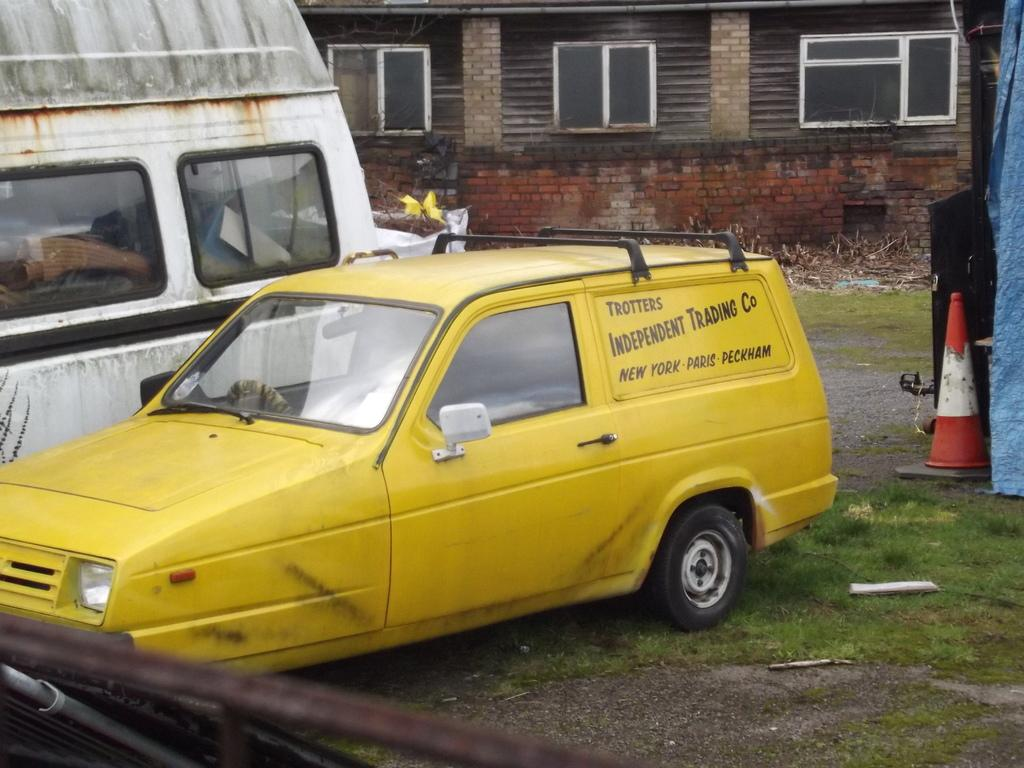Provide a one-sentence caption for the provided image. A yellow station wagon is parked in a yard and says Trotters Independent Trading Co. 